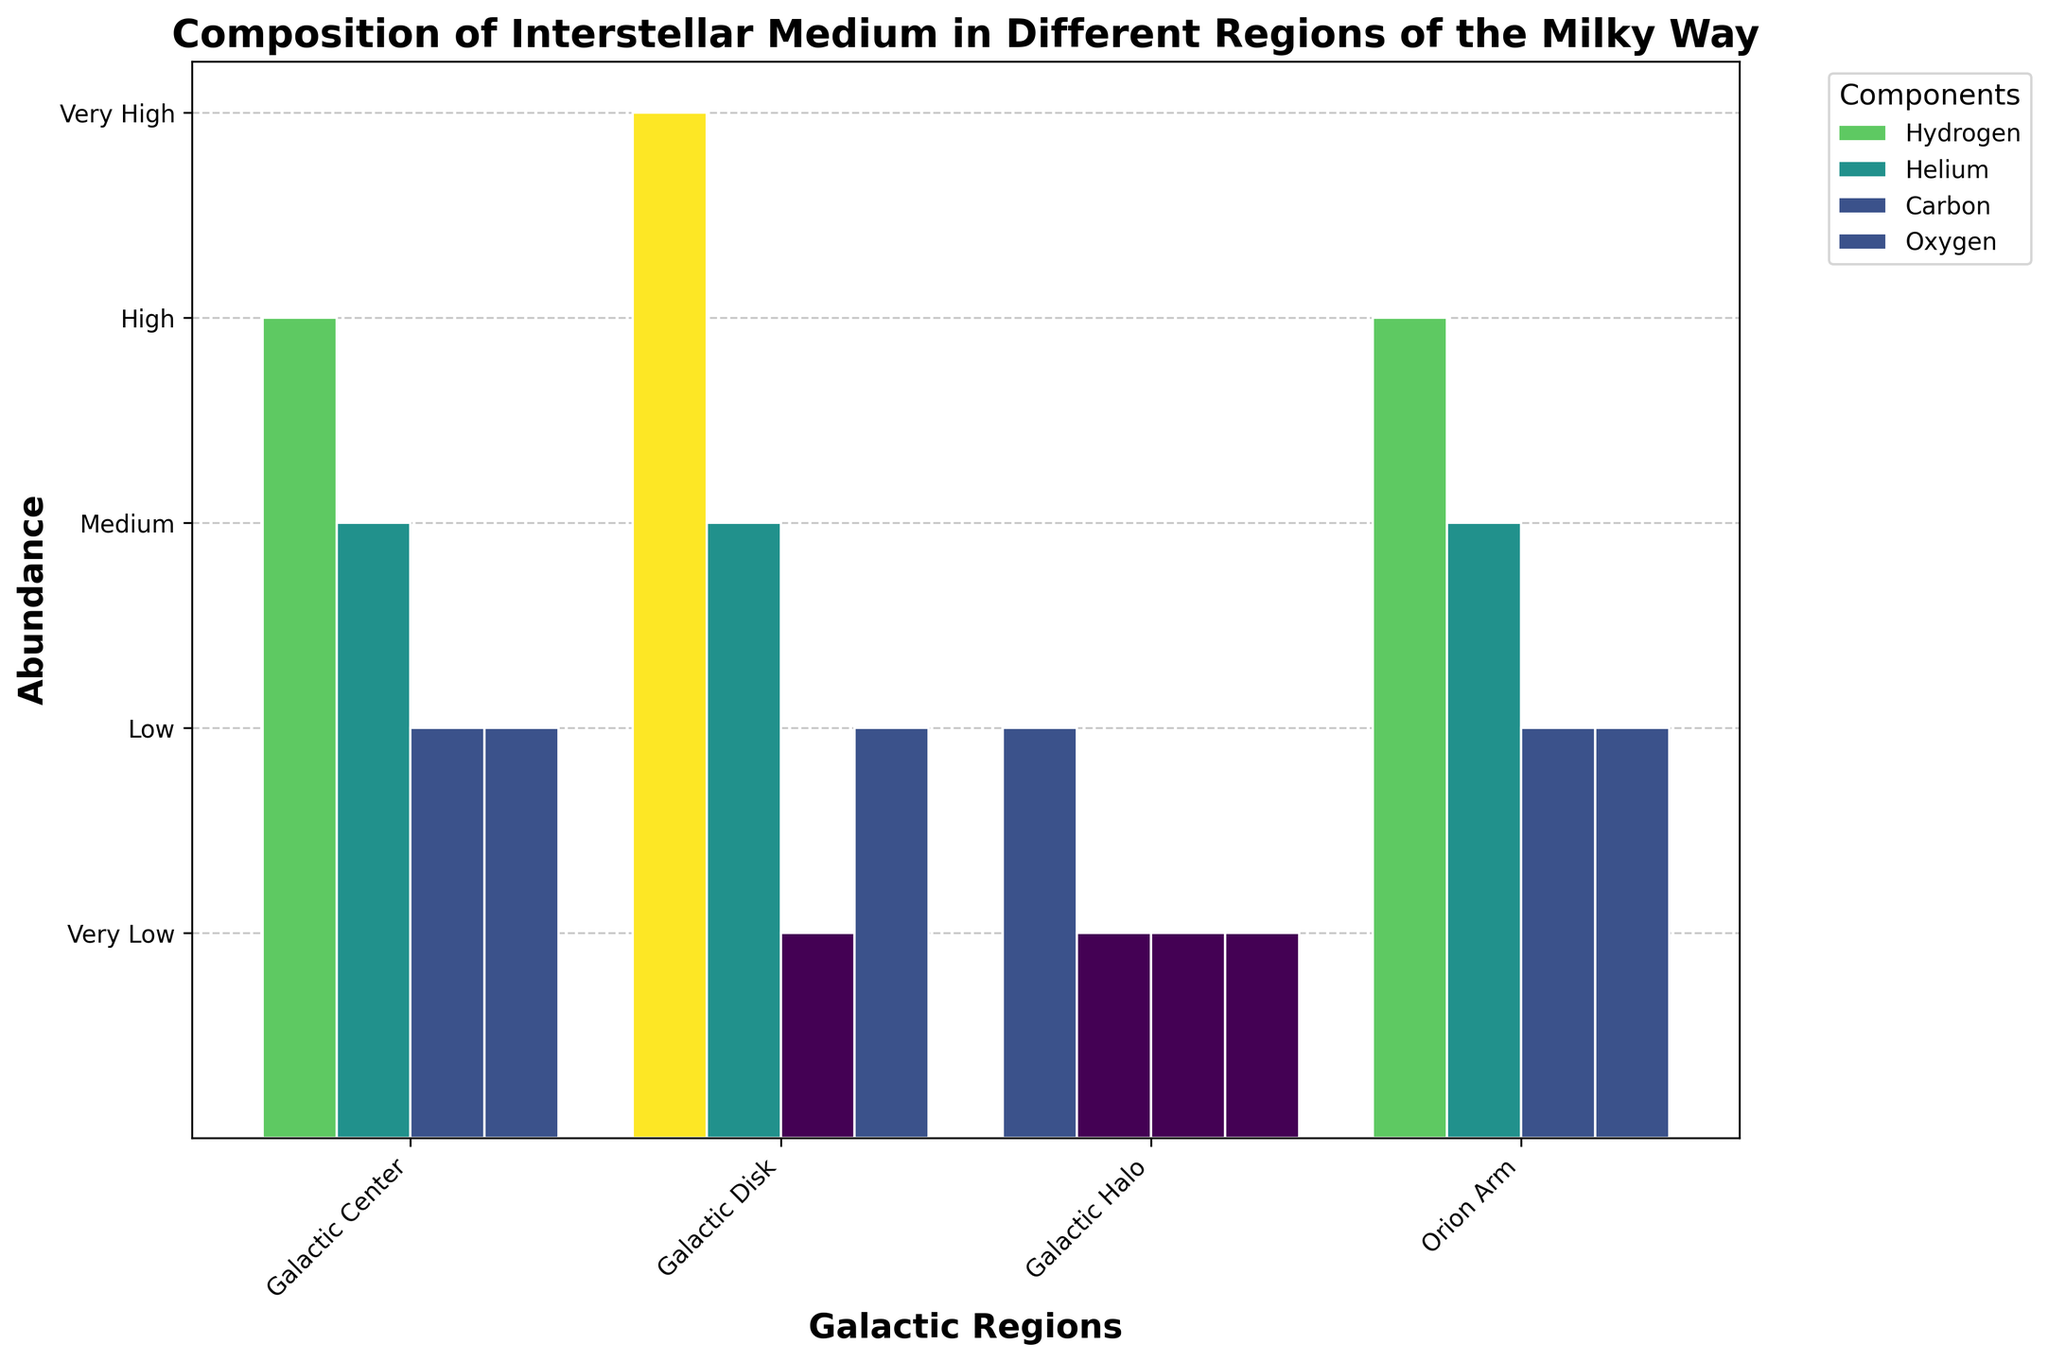What is the title of the figure? The title is written at the top center of the figure. It reads "Composition of Interstellar Medium in Different Regions of the Milky Way".
Answer: "Composition of Interstellar Medium in Different Regions of the Milky Way" What are the categories of the x-axis? The categories on the x-axis are labeled below each bar group. They are Galactic Center, Galactic Disk, Galactic Halo, and Orion Arm.
Answer: Galactic Center, Galactic Disk, Galactic Halo, Orion Arm Which component has the highest abundance in the Galactic Center? Look at the bars corresponding to the Galactic Center region. The tallest bar in this group is for Hydrogen, indicating it has the highest abundance.
Answer: Hydrogen What is the abundance level of Carbon in the Galactic Halo? Check the bar heights for the Galactic Halo. The bar for Carbon is at the lowest level, which corresponds to the "Very Low" abundance on the y-axis.
Answer: Very Low Which region has the highest abundance of Hydrogen? Compare the heights of Hydrogen bars across all the regions. The Hydrogen bar in the Galactic Disk is the tallest, corresponding to "Very High" abundance.
Answer: Galactic Disk List the components in the Orion Arm along with their abundance levels. Observe the bars for the Orion Arm. Hydrogen’s bar is at "High", Helium’s bar is at "Medium", Carbon’s bar is at "Low", and Oxygen’s bar is at "Low".
Answer: Hydrogen: High, Helium: Medium, Carbon: Low, Oxygen: Low How does the abundance of Helium in the Galactic Disk compare to that in the Galaxy Center? Compare the height of the Helium bars in the Galactic Disk and Galactic Center. Both bars are at the same height level, which is "Medium".
Answer: Equal, both Medium Which component shows the greatest variation in abundance across different regions? Look for a component where the bar heights vary the most across different regions. Hydrogen shows the greatest variation, ranging from "Very High" in the Galactic Disk to "Low" in the Galactic Halo.
Answer: Hydrogen Calculate the average abundance level of Oxygen across all regions. Find the abundance levels: Low in Galactic Center, Low in Galactic Disk, Very Low in Galactic Halo, and Low in Orion Arm. Averaging these: (2 + 2 + 1 + 2) / 4 = 1.75, which corresponds to a mix of Low and Very Low.
Answer: Low to Very Low Is there any region that does not have at least one component with a "Medium" or higher abundance? Check each region to see if all components are below "Medium". The Galactic Halo has all components at "Very Low" or "Low".
Answer: Galactic Halo 